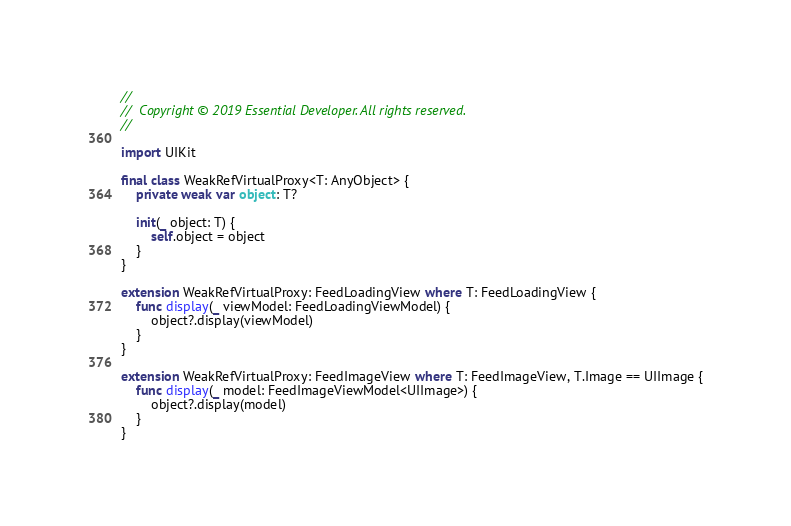<code> <loc_0><loc_0><loc_500><loc_500><_Swift_>//
//  Copyright © 2019 Essential Developer. All rights reserved.
//

import UIKit

final class WeakRefVirtualProxy<T: AnyObject> {
	private weak var object: T?

	init(_ object: T) {
		self.object = object
	}
}

extension WeakRefVirtualProxy: FeedLoadingView where T: FeedLoadingView {
	func display(_ viewModel: FeedLoadingViewModel) {
		object?.display(viewModel)
	}
}

extension WeakRefVirtualProxy: FeedImageView where T: FeedImageView, T.Image == UIImage {
	func display(_ model: FeedImageViewModel<UIImage>) {
		object?.display(model)
	}
}
</code> 